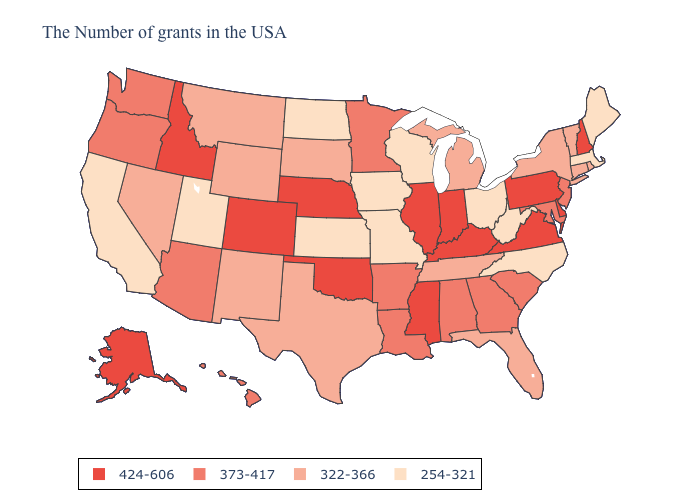Name the states that have a value in the range 373-417?
Write a very short answer. New Jersey, Maryland, South Carolina, Georgia, Alabama, Louisiana, Arkansas, Minnesota, Arizona, Washington, Oregon, Hawaii. What is the value of Wisconsin?
Quick response, please. 254-321. Name the states that have a value in the range 424-606?
Be succinct. New Hampshire, Delaware, Pennsylvania, Virginia, Kentucky, Indiana, Illinois, Mississippi, Nebraska, Oklahoma, Colorado, Idaho, Alaska. Name the states that have a value in the range 373-417?
Give a very brief answer. New Jersey, Maryland, South Carolina, Georgia, Alabama, Louisiana, Arkansas, Minnesota, Arizona, Washington, Oregon, Hawaii. Which states have the lowest value in the USA?
Answer briefly. Maine, Massachusetts, North Carolina, West Virginia, Ohio, Wisconsin, Missouri, Iowa, Kansas, North Dakota, Utah, California. Name the states that have a value in the range 254-321?
Keep it brief. Maine, Massachusetts, North Carolina, West Virginia, Ohio, Wisconsin, Missouri, Iowa, Kansas, North Dakota, Utah, California. Name the states that have a value in the range 322-366?
Answer briefly. Rhode Island, Vermont, Connecticut, New York, Florida, Michigan, Tennessee, Texas, South Dakota, Wyoming, New Mexico, Montana, Nevada. Name the states that have a value in the range 254-321?
Answer briefly. Maine, Massachusetts, North Carolina, West Virginia, Ohio, Wisconsin, Missouri, Iowa, Kansas, North Dakota, Utah, California. Does Utah have the lowest value in the West?
Give a very brief answer. Yes. What is the value of Hawaii?
Write a very short answer. 373-417. Which states hav the highest value in the South?
Short answer required. Delaware, Virginia, Kentucky, Mississippi, Oklahoma. What is the value of Florida?
Be succinct. 322-366. What is the highest value in the Northeast ?
Be succinct. 424-606. Does the map have missing data?
Concise answer only. No. How many symbols are there in the legend?
Keep it brief. 4. 